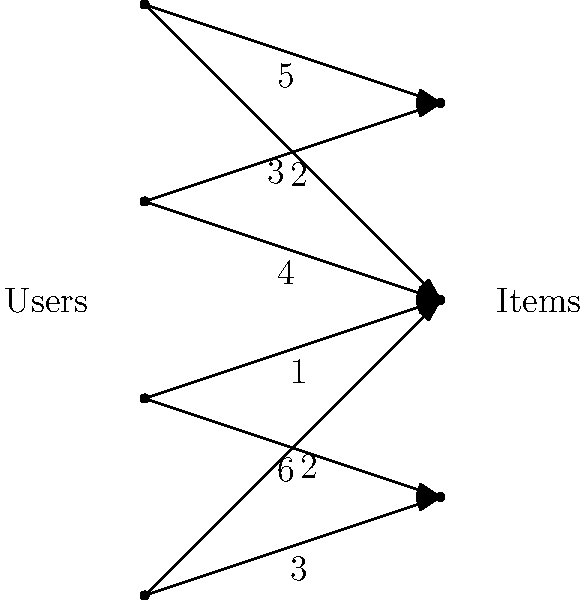Given the bipartite graph representing user-item interactions, where edges indicate potential recommendations and their weights represent the strength of the recommendation, what is the maximum flow (total recommendation strength) that can be achieved in this network? To find the maximum flow in this bipartite graph, we'll use the Ford-Fulkerson algorithm:

1. Initialize flow to 0 for all edges.

2. Find augmenting paths from any user to any item:
   a) Path 1: U[0] -> V[0] (flow 5)
      New flow: 5
   b) Path 2: U[1] -> V[1] (flow 4)
      New flow: 9
   c) Path 3: U[2] -> V[2] (flow 6)
      New flow: 15
   d) Path 4: U[3] -> V[1] (flow 2)
      New flow: 17
   e) Path 5: U[0] -> V[1] (flow 1)
      New flow: 18
   f) No more augmenting paths exist

3. The maximum flow is the sum of all flows: 18

This maximum flow represents the optimal way to assign recommendations to users, maximizing the total strength of recommendations while respecting the capacity constraints of each edge.
Answer: 18 